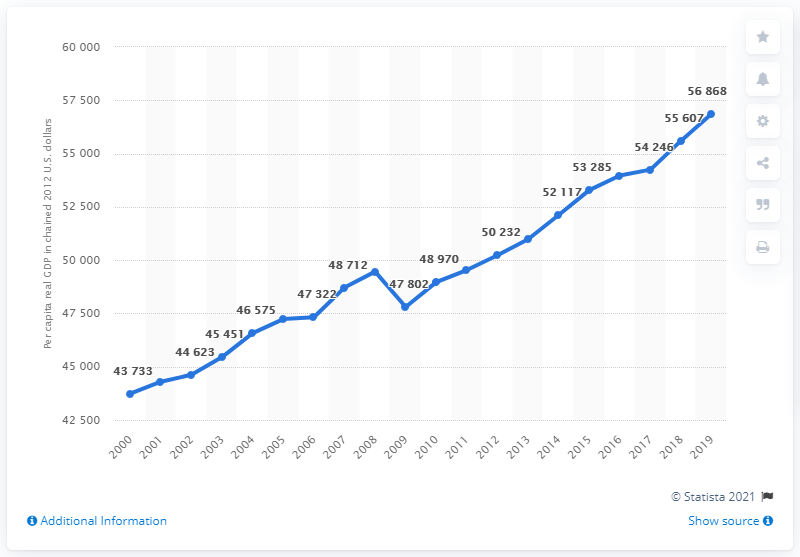Outline some significant characteristics in this image. In the year 2012, the per capita real GDP of Pennsylvania was $56,868, when adjusted for inflation using the chain price index. 